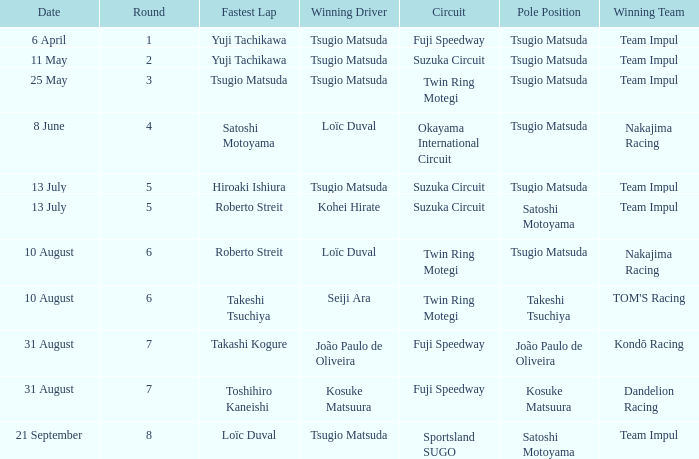What is the fastest lap for Seiji Ara? Takeshi Tsuchiya. 